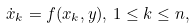Convert formula to latex. <formula><loc_0><loc_0><loc_500><loc_500>\dot { x } _ { k } = f ( x _ { k } , y ) , \, 1 \leq k \leq n ,</formula> 